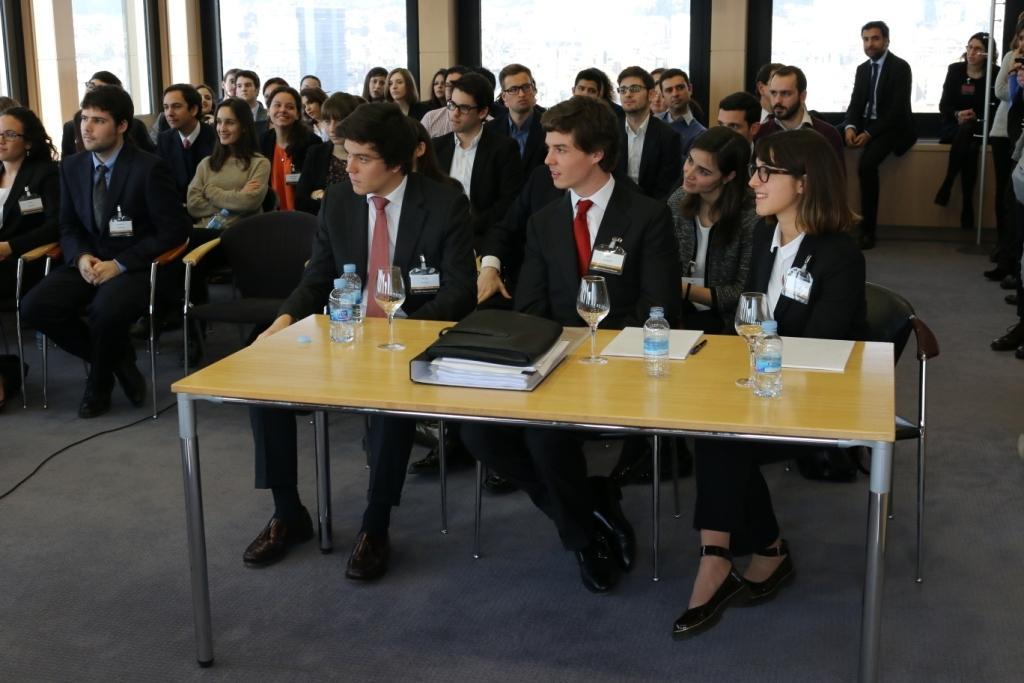Please provide a concise description of this image. This image is clicked in a classroom. There are many persons in this image, most of them are wearing black suits. In the front, there is a table which there are glass, bottles and books. 